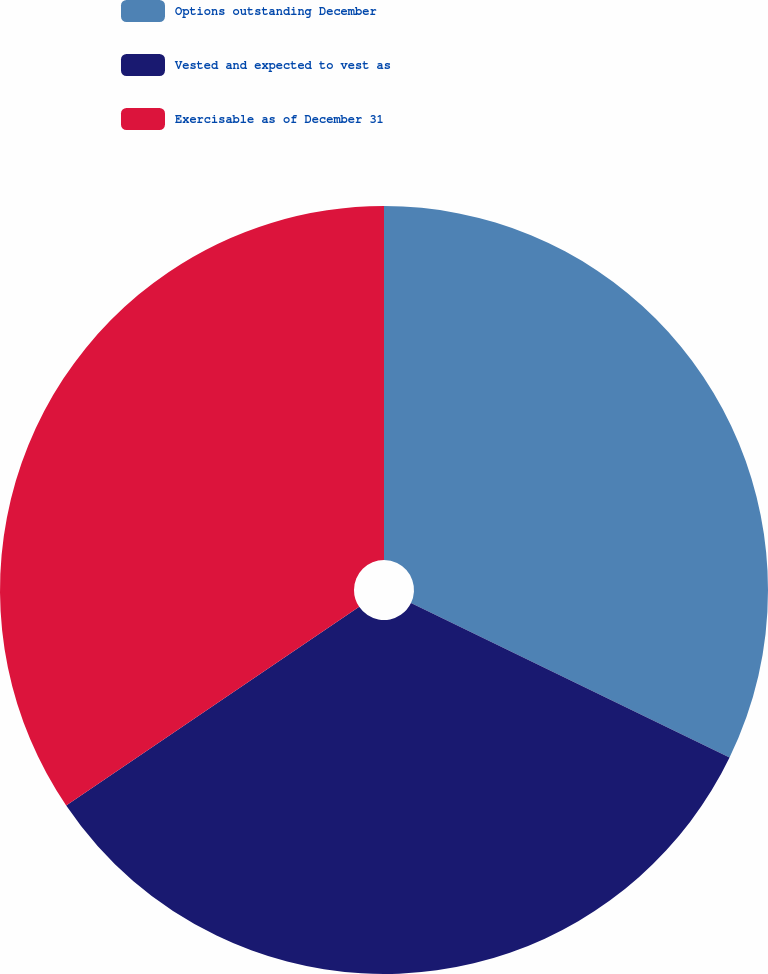Convert chart. <chart><loc_0><loc_0><loc_500><loc_500><pie_chart><fcel>Options outstanding December<fcel>Vested and expected to vest as<fcel>Exercisable as of December 31<nl><fcel>32.18%<fcel>33.33%<fcel>34.48%<nl></chart> 